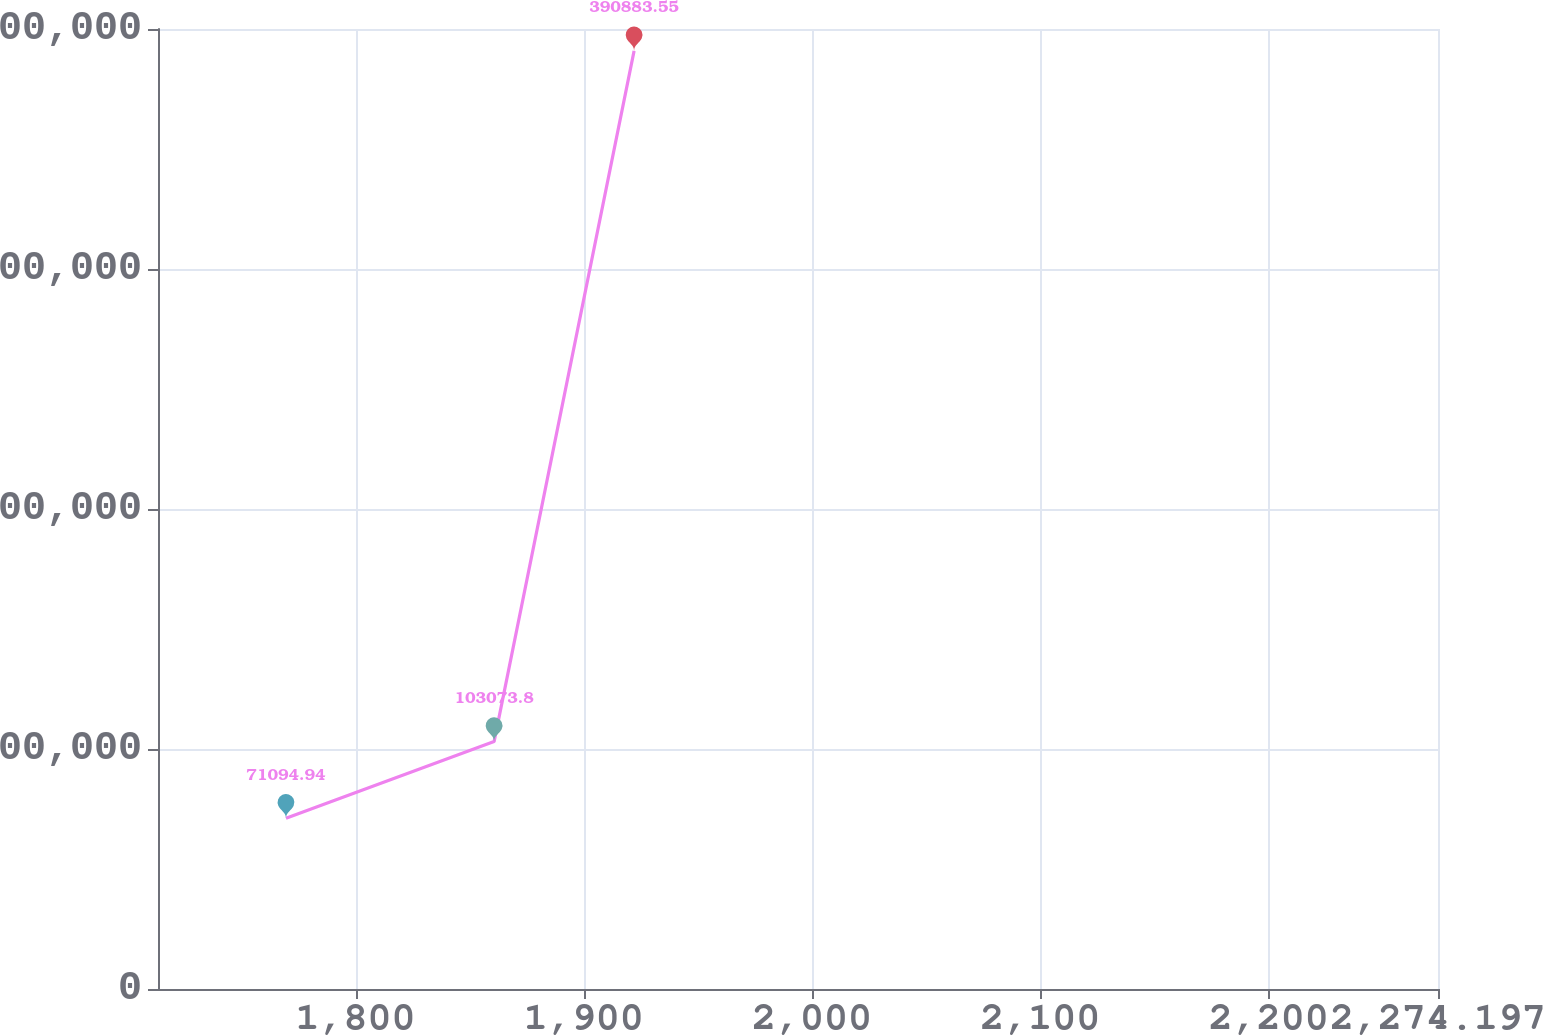<chart> <loc_0><loc_0><loc_500><loc_500><line_chart><ecel><fcel>(in thousands) $ 44,000<nl><fcel>1769.54<fcel>71094.9<nl><fcel>1860.7<fcel>103074<nl><fcel>1922.03<fcel>390884<nl><fcel>2330.27<fcel>278589<nl></chart> 